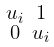Convert formula to latex. <formula><loc_0><loc_0><loc_500><loc_500>\begin{smallmatrix} u _ { i } & 1 \\ 0 & u _ { i } \end{smallmatrix}</formula> 